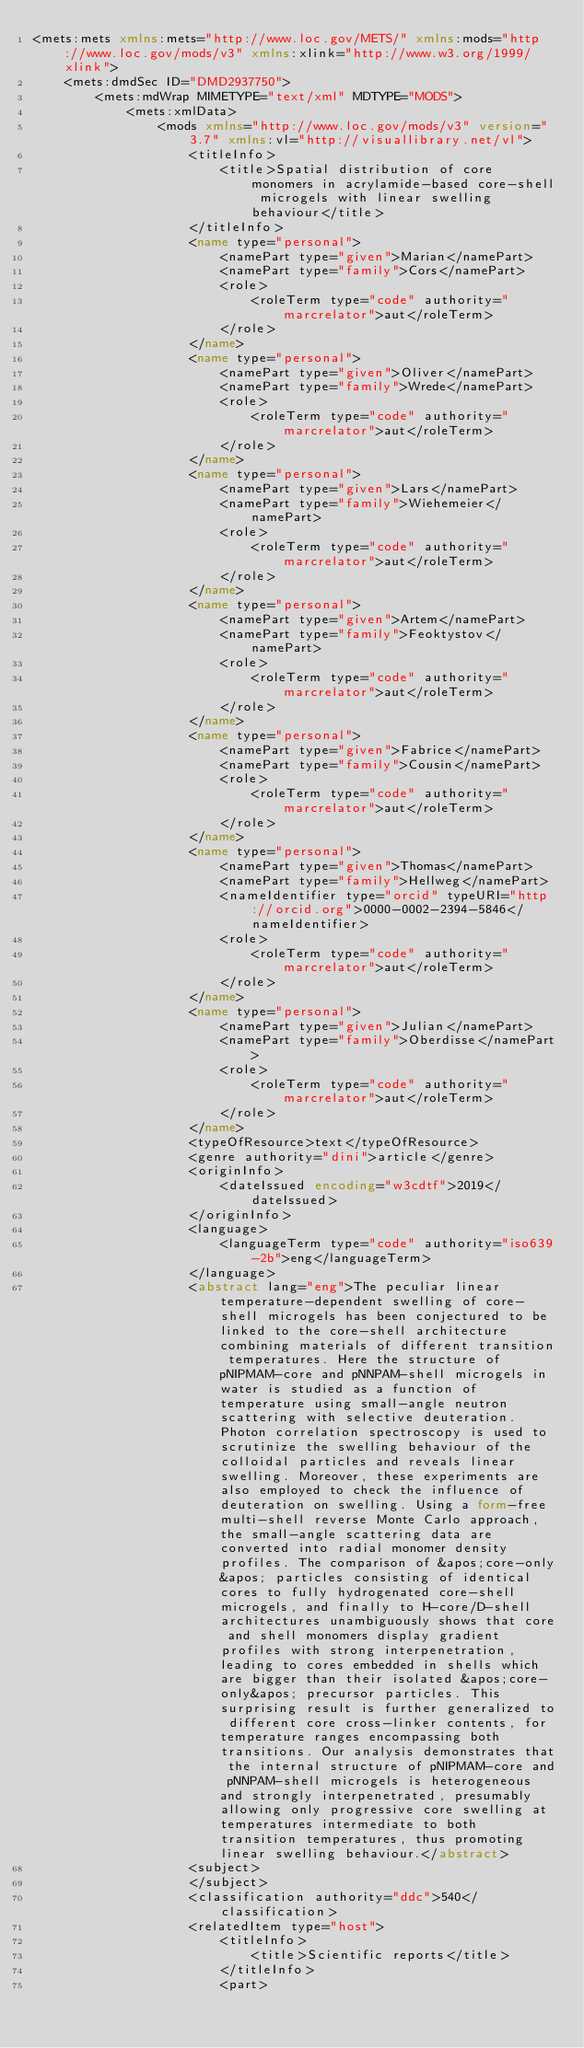Convert code to text. <code><loc_0><loc_0><loc_500><loc_500><_XML_><mets:mets xmlns:mets="http://www.loc.gov/METS/" xmlns:mods="http://www.loc.gov/mods/v3" xmlns:xlink="http://www.w3.org/1999/xlink">
    <mets:dmdSec ID="DMD2937750">
        <mets:mdWrap MIMETYPE="text/xml" MDTYPE="MODS">
            <mets:xmlData>
                <mods xmlns="http://www.loc.gov/mods/v3" version="3.7" xmlns:vl="http://visuallibrary.net/vl">
                    <titleInfo>
                        <title>Spatial distribution of core monomers in acrylamide-based core-shell microgels with linear swelling behaviour</title>
                    </titleInfo>
                    <name type="personal">
                        <namePart type="given">Marian</namePart>
                        <namePart type="family">Cors</namePart>
                        <role>
                            <roleTerm type="code" authority="marcrelator">aut</roleTerm>
                        </role>
                    </name>
                    <name type="personal">
                        <namePart type="given">Oliver</namePart>
                        <namePart type="family">Wrede</namePart>
                        <role>
                            <roleTerm type="code" authority="marcrelator">aut</roleTerm>
                        </role>
                    </name>
                    <name type="personal">
                        <namePart type="given">Lars</namePart>
                        <namePart type="family">Wiehemeier</namePart>
                        <role>
                            <roleTerm type="code" authority="marcrelator">aut</roleTerm>
                        </role>
                    </name>
                    <name type="personal">
                        <namePart type="given">Artem</namePart>
                        <namePart type="family">Feoktystov</namePart>
                        <role>
                            <roleTerm type="code" authority="marcrelator">aut</roleTerm>
                        </role>
                    </name>
                    <name type="personal">
                        <namePart type="given">Fabrice</namePart>
                        <namePart type="family">Cousin</namePart>
                        <role>
                            <roleTerm type="code" authority="marcrelator">aut</roleTerm>
                        </role>
                    </name>
                    <name type="personal">
                        <namePart type="given">Thomas</namePart>
                        <namePart type="family">Hellweg</namePart>
                        <nameIdentifier type="orcid" typeURI="http://orcid.org">0000-0002-2394-5846</nameIdentifier>
                        <role>
                            <roleTerm type="code" authority="marcrelator">aut</roleTerm>
                        </role>
                    </name>
                    <name type="personal">
                        <namePart type="given">Julian</namePart>
                        <namePart type="family">Oberdisse</namePart>
                        <role>
                            <roleTerm type="code" authority="marcrelator">aut</roleTerm>
                        </role>
                    </name>
                    <typeOfResource>text</typeOfResource>
                    <genre authority="dini">article</genre>
                    <originInfo>
                        <dateIssued encoding="w3cdtf">2019</dateIssued>
                    </originInfo>
                    <language>
                        <languageTerm type="code" authority="iso639-2b">eng</languageTerm>
                    </language>
                    <abstract lang="eng">The peculiar linear temperature-dependent swelling of core-shell microgels has been conjectured to be linked to the core-shell architecture combining materials of different transition temperatures. Here the structure of pNIPMAM-core and pNNPAM-shell microgels in water is studied as a function of temperature using small-angle neutron scattering with selective deuteration. Photon correlation spectroscopy is used to scrutinize the swelling behaviour of the colloidal particles and reveals linear swelling. Moreover, these experiments are also employed to check the influence of deuteration on swelling. Using a form-free multi-shell reverse Monte Carlo approach, the small-angle scattering data are converted into radial monomer density profiles. The comparison of &apos;core-only&apos; particles consisting of identical cores to fully hydrogenated core-shell microgels, and finally to H-core/D-shell architectures unambiguously shows that core and shell monomers display gradient profiles with strong interpenetration, leading to cores embedded in shells which are bigger than their isolated &apos;core-only&apos; precursor particles. This surprising result is further generalized to different core cross-linker contents, for temperature ranges encompassing both transitions. Our analysis demonstrates that the internal structure of pNIPMAM-core and pNNPAM-shell microgels is heterogeneous and strongly interpenetrated, presumably allowing only progressive core swelling at temperatures intermediate to both transition temperatures, thus promoting linear swelling behaviour.</abstract>
                    <subject>
                    </subject>
                    <classification authority="ddc">540</classification>
                    <relatedItem type="host">
                        <titleInfo>
                            <title>Scientific reports</title>
                        </titleInfo>
                        <part></code> 